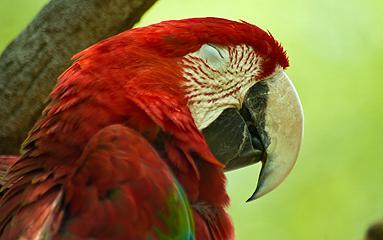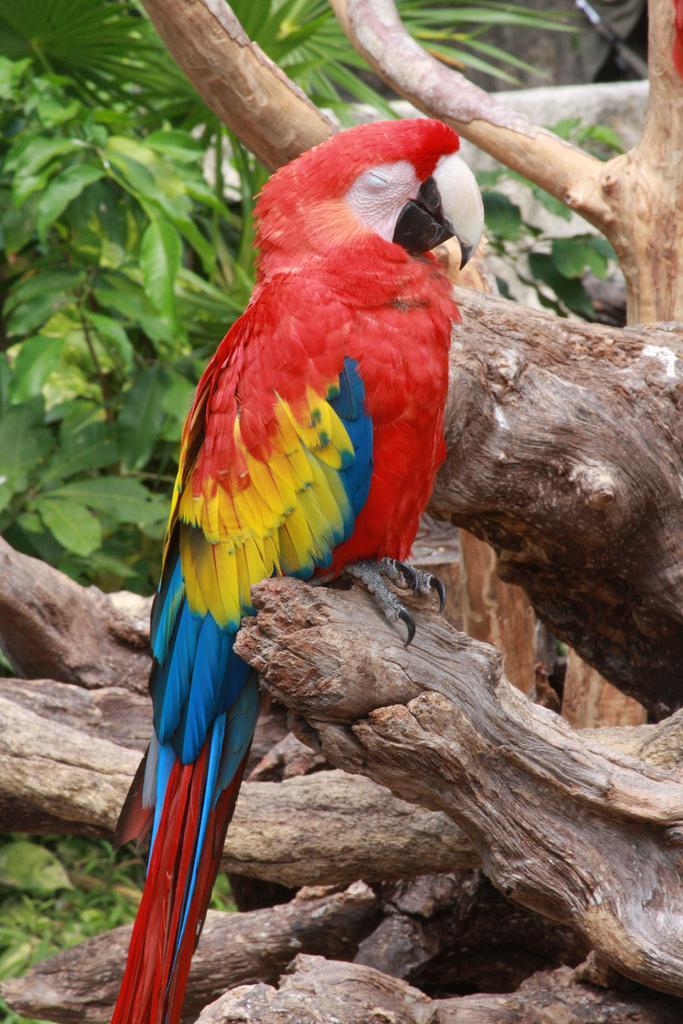The first image is the image on the left, the second image is the image on the right. Considering the images on both sides, is "Each image shows a red-headed bird with its face in profile and its eye shut." valid? Answer yes or no. Yes. The first image is the image on the left, the second image is the image on the right. Examine the images to the left and right. Is the description "The bird in the image on the right has its eyes closed." accurate? Answer yes or no. Yes. 